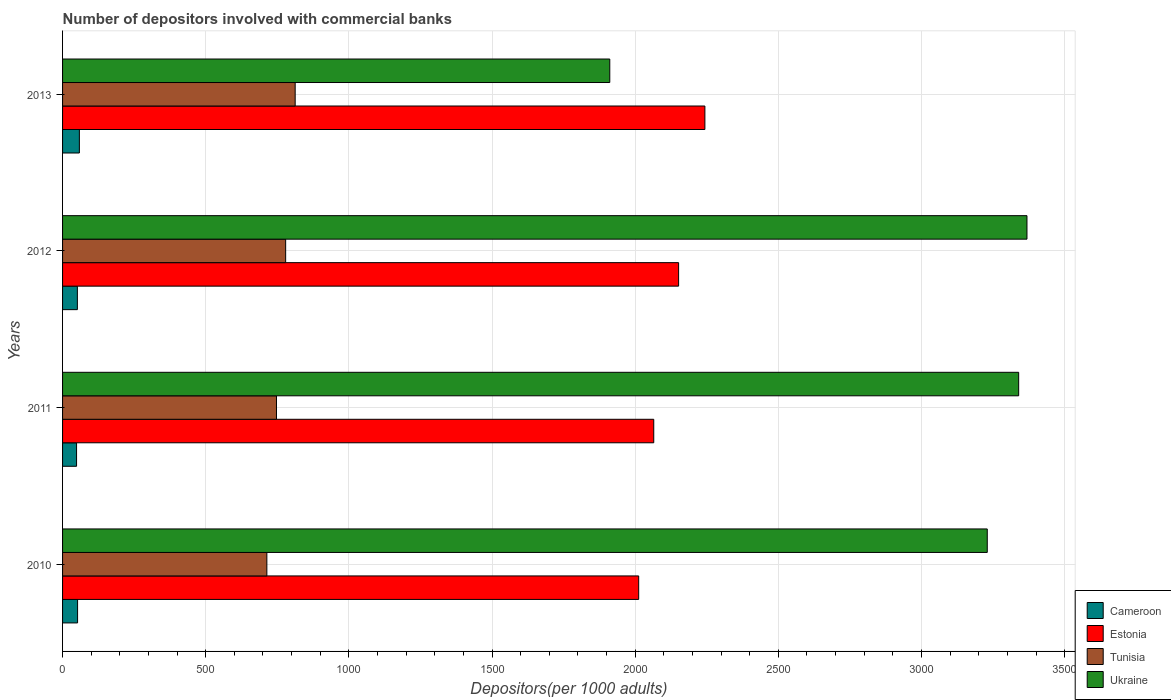Are the number of bars per tick equal to the number of legend labels?
Make the answer very short. Yes. How many bars are there on the 2nd tick from the top?
Offer a very short reply. 4. What is the label of the 4th group of bars from the top?
Give a very brief answer. 2010. What is the number of depositors involved with commercial banks in Tunisia in 2010?
Your answer should be compact. 713.56. Across all years, what is the maximum number of depositors involved with commercial banks in Estonia?
Offer a terse response. 2243.44. Across all years, what is the minimum number of depositors involved with commercial banks in Tunisia?
Offer a terse response. 713.56. What is the total number of depositors involved with commercial banks in Tunisia in the graph?
Your answer should be very brief. 3052.28. What is the difference between the number of depositors involved with commercial banks in Cameroon in 2012 and that in 2013?
Offer a terse response. -6.99. What is the difference between the number of depositors involved with commercial banks in Cameroon in 2011 and the number of depositors involved with commercial banks in Ukraine in 2013?
Keep it short and to the point. -1862.32. What is the average number of depositors involved with commercial banks in Estonia per year?
Your answer should be very brief. 2118.04. In the year 2010, what is the difference between the number of depositors involved with commercial banks in Estonia and number of depositors involved with commercial banks in Cameroon?
Offer a very short reply. 1959.79. What is the ratio of the number of depositors involved with commercial banks in Estonia in 2010 to that in 2013?
Provide a short and direct response. 0.9. Is the number of depositors involved with commercial banks in Tunisia in 2010 less than that in 2013?
Your answer should be very brief. Yes. What is the difference between the highest and the second highest number of depositors involved with commercial banks in Estonia?
Your response must be concise. 91.77. What is the difference between the highest and the lowest number of depositors involved with commercial banks in Tunisia?
Keep it short and to the point. 98.87. In how many years, is the number of depositors involved with commercial banks in Tunisia greater than the average number of depositors involved with commercial banks in Tunisia taken over all years?
Offer a terse response. 2. Is the sum of the number of depositors involved with commercial banks in Cameroon in 2011 and 2013 greater than the maximum number of depositors involved with commercial banks in Tunisia across all years?
Your answer should be very brief. No. What does the 3rd bar from the top in 2013 represents?
Your answer should be compact. Estonia. What does the 3rd bar from the bottom in 2010 represents?
Your answer should be very brief. Tunisia. How many bars are there?
Your response must be concise. 16. Are all the bars in the graph horizontal?
Make the answer very short. Yes. What is the difference between two consecutive major ticks on the X-axis?
Your answer should be compact. 500. Are the values on the major ticks of X-axis written in scientific E-notation?
Provide a succinct answer. No. Does the graph contain any zero values?
Offer a terse response. No. What is the title of the graph?
Provide a succinct answer. Number of depositors involved with commercial banks. Does "Ethiopia" appear as one of the legend labels in the graph?
Offer a terse response. No. What is the label or title of the X-axis?
Your response must be concise. Depositors(per 1000 adults). What is the Depositors(per 1000 adults) of Cameroon in 2010?
Ensure brevity in your answer.  52.42. What is the Depositors(per 1000 adults) in Estonia in 2010?
Offer a very short reply. 2012.21. What is the Depositors(per 1000 adults) of Tunisia in 2010?
Keep it short and to the point. 713.56. What is the Depositors(per 1000 adults) of Ukraine in 2010?
Your answer should be very brief. 3229.69. What is the Depositors(per 1000 adults) in Cameroon in 2011?
Make the answer very short. 48.91. What is the Depositors(per 1000 adults) in Estonia in 2011?
Keep it short and to the point. 2064.84. What is the Depositors(per 1000 adults) in Tunisia in 2011?
Ensure brevity in your answer.  747.13. What is the Depositors(per 1000 adults) in Ukraine in 2011?
Your answer should be very brief. 3339.41. What is the Depositors(per 1000 adults) of Cameroon in 2012?
Your answer should be compact. 51.71. What is the Depositors(per 1000 adults) in Estonia in 2012?
Your answer should be compact. 2151.67. What is the Depositors(per 1000 adults) in Tunisia in 2012?
Provide a short and direct response. 779.16. What is the Depositors(per 1000 adults) in Ukraine in 2012?
Your response must be concise. 3368.39. What is the Depositors(per 1000 adults) in Cameroon in 2013?
Offer a very short reply. 58.7. What is the Depositors(per 1000 adults) of Estonia in 2013?
Offer a terse response. 2243.44. What is the Depositors(per 1000 adults) in Tunisia in 2013?
Keep it short and to the point. 812.43. What is the Depositors(per 1000 adults) of Ukraine in 2013?
Ensure brevity in your answer.  1911.24. Across all years, what is the maximum Depositors(per 1000 adults) of Cameroon?
Give a very brief answer. 58.7. Across all years, what is the maximum Depositors(per 1000 adults) of Estonia?
Offer a very short reply. 2243.44. Across all years, what is the maximum Depositors(per 1000 adults) in Tunisia?
Make the answer very short. 812.43. Across all years, what is the maximum Depositors(per 1000 adults) of Ukraine?
Provide a succinct answer. 3368.39. Across all years, what is the minimum Depositors(per 1000 adults) in Cameroon?
Your response must be concise. 48.91. Across all years, what is the minimum Depositors(per 1000 adults) of Estonia?
Your answer should be very brief. 2012.21. Across all years, what is the minimum Depositors(per 1000 adults) of Tunisia?
Offer a very short reply. 713.56. Across all years, what is the minimum Depositors(per 1000 adults) in Ukraine?
Make the answer very short. 1911.24. What is the total Depositors(per 1000 adults) of Cameroon in the graph?
Provide a succinct answer. 211.74. What is the total Depositors(per 1000 adults) of Estonia in the graph?
Offer a terse response. 8472.16. What is the total Depositors(per 1000 adults) in Tunisia in the graph?
Offer a terse response. 3052.28. What is the total Depositors(per 1000 adults) of Ukraine in the graph?
Give a very brief answer. 1.18e+04. What is the difference between the Depositors(per 1000 adults) in Cameroon in 2010 and that in 2011?
Provide a succinct answer. 3.51. What is the difference between the Depositors(per 1000 adults) of Estonia in 2010 and that in 2011?
Ensure brevity in your answer.  -52.62. What is the difference between the Depositors(per 1000 adults) in Tunisia in 2010 and that in 2011?
Offer a terse response. -33.57. What is the difference between the Depositors(per 1000 adults) in Ukraine in 2010 and that in 2011?
Offer a very short reply. -109.71. What is the difference between the Depositors(per 1000 adults) in Cameroon in 2010 and that in 2012?
Give a very brief answer. 0.71. What is the difference between the Depositors(per 1000 adults) in Estonia in 2010 and that in 2012?
Make the answer very short. -139.46. What is the difference between the Depositors(per 1000 adults) of Tunisia in 2010 and that in 2012?
Offer a very short reply. -65.61. What is the difference between the Depositors(per 1000 adults) in Ukraine in 2010 and that in 2012?
Provide a short and direct response. -138.7. What is the difference between the Depositors(per 1000 adults) in Cameroon in 2010 and that in 2013?
Offer a terse response. -6.28. What is the difference between the Depositors(per 1000 adults) in Estonia in 2010 and that in 2013?
Offer a very short reply. -231.23. What is the difference between the Depositors(per 1000 adults) of Tunisia in 2010 and that in 2013?
Your answer should be very brief. -98.87. What is the difference between the Depositors(per 1000 adults) in Ukraine in 2010 and that in 2013?
Offer a terse response. 1318.46. What is the difference between the Depositors(per 1000 adults) of Cameroon in 2011 and that in 2012?
Offer a very short reply. -2.8. What is the difference between the Depositors(per 1000 adults) of Estonia in 2011 and that in 2012?
Keep it short and to the point. -86.83. What is the difference between the Depositors(per 1000 adults) of Tunisia in 2011 and that in 2012?
Provide a succinct answer. -32.03. What is the difference between the Depositors(per 1000 adults) of Ukraine in 2011 and that in 2012?
Your answer should be compact. -28.98. What is the difference between the Depositors(per 1000 adults) in Cameroon in 2011 and that in 2013?
Your response must be concise. -9.79. What is the difference between the Depositors(per 1000 adults) in Estonia in 2011 and that in 2013?
Provide a succinct answer. -178.61. What is the difference between the Depositors(per 1000 adults) in Tunisia in 2011 and that in 2013?
Provide a succinct answer. -65.3. What is the difference between the Depositors(per 1000 adults) in Ukraine in 2011 and that in 2013?
Provide a succinct answer. 1428.17. What is the difference between the Depositors(per 1000 adults) in Cameroon in 2012 and that in 2013?
Provide a succinct answer. -6.99. What is the difference between the Depositors(per 1000 adults) in Estonia in 2012 and that in 2013?
Provide a succinct answer. -91.77. What is the difference between the Depositors(per 1000 adults) of Tunisia in 2012 and that in 2013?
Keep it short and to the point. -33.26. What is the difference between the Depositors(per 1000 adults) of Ukraine in 2012 and that in 2013?
Your answer should be compact. 1457.15. What is the difference between the Depositors(per 1000 adults) of Cameroon in 2010 and the Depositors(per 1000 adults) of Estonia in 2011?
Provide a short and direct response. -2012.42. What is the difference between the Depositors(per 1000 adults) of Cameroon in 2010 and the Depositors(per 1000 adults) of Tunisia in 2011?
Your answer should be compact. -694.71. What is the difference between the Depositors(per 1000 adults) in Cameroon in 2010 and the Depositors(per 1000 adults) in Ukraine in 2011?
Give a very brief answer. -3286.98. What is the difference between the Depositors(per 1000 adults) of Estonia in 2010 and the Depositors(per 1000 adults) of Tunisia in 2011?
Make the answer very short. 1265.08. What is the difference between the Depositors(per 1000 adults) in Estonia in 2010 and the Depositors(per 1000 adults) in Ukraine in 2011?
Ensure brevity in your answer.  -1327.19. What is the difference between the Depositors(per 1000 adults) in Tunisia in 2010 and the Depositors(per 1000 adults) in Ukraine in 2011?
Offer a terse response. -2625.85. What is the difference between the Depositors(per 1000 adults) of Cameroon in 2010 and the Depositors(per 1000 adults) of Estonia in 2012?
Your answer should be very brief. -2099.25. What is the difference between the Depositors(per 1000 adults) of Cameroon in 2010 and the Depositors(per 1000 adults) of Tunisia in 2012?
Offer a terse response. -726.74. What is the difference between the Depositors(per 1000 adults) in Cameroon in 2010 and the Depositors(per 1000 adults) in Ukraine in 2012?
Ensure brevity in your answer.  -3315.97. What is the difference between the Depositors(per 1000 adults) in Estonia in 2010 and the Depositors(per 1000 adults) in Tunisia in 2012?
Give a very brief answer. 1233.05. What is the difference between the Depositors(per 1000 adults) in Estonia in 2010 and the Depositors(per 1000 adults) in Ukraine in 2012?
Provide a short and direct response. -1356.17. What is the difference between the Depositors(per 1000 adults) in Tunisia in 2010 and the Depositors(per 1000 adults) in Ukraine in 2012?
Make the answer very short. -2654.83. What is the difference between the Depositors(per 1000 adults) in Cameroon in 2010 and the Depositors(per 1000 adults) in Estonia in 2013?
Provide a short and direct response. -2191.02. What is the difference between the Depositors(per 1000 adults) of Cameroon in 2010 and the Depositors(per 1000 adults) of Tunisia in 2013?
Provide a short and direct response. -760. What is the difference between the Depositors(per 1000 adults) in Cameroon in 2010 and the Depositors(per 1000 adults) in Ukraine in 2013?
Keep it short and to the point. -1858.81. What is the difference between the Depositors(per 1000 adults) in Estonia in 2010 and the Depositors(per 1000 adults) in Tunisia in 2013?
Provide a short and direct response. 1199.79. What is the difference between the Depositors(per 1000 adults) in Estonia in 2010 and the Depositors(per 1000 adults) in Ukraine in 2013?
Offer a terse response. 100.98. What is the difference between the Depositors(per 1000 adults) in Tunisia in 2010 and the Depositors(per 1000 adults) in Ukraine in 2013?
Ensure brevity in your answer.  -1197.68. What is the difference between the Depositors(per 1000 adults) in Cameroon in 2011 and the Depositors(per 1000 adults) in Estonia in 2012?
Your answer should be very brief. -2102.76. What is the difference between the Depositors(per 1000 adults) of Cameroon in 2011 and the Depositors(per 1000 adults) of Tunisia in 2012?
Give a very brief answer. -730.25. What is the difference between the Depositors(per 1000 adults) in Cameroon in 2011 and the Depositors(per 1000 adults) in Ukraine in 2012?
Provide a succinct answer. -3319.48. What is the difference between the Depositors(per 1000 adults) in Estonia in 2011 and the Depositors(per 1000 adults) in Tunisia in 2012?
Give a very brief answer. 1285.67. What is the difference between the Depositors(per 1000 adults) of Estonia in 2011 and the Depositors(per 1000 adults) of Ukraine in 2012?
Your answer should be very brief. -1303.55. What is the difference between the Depositors(per 1000 adults) in Tunisia in 2011 and the Depositors(per 1000 adults) in Ukraine in 2012?
Your answer should be very brief. -2621.26. What is the difference between the Depositors(per 1000 adults) in Cameroon in 2011 and the Depositors(per 1000 adults) in Estonia in 2013?
Your response must be concise. -2194.53. What is the difference between the Depositors(per 1000 adults) in Cameroon in 2011 and the Depositors(per 1000 adults) in Tunisia in 2013?
Your answer should be very brief. -763.52. What is the difference between the Depositors(per 1000 adults) of Cameroon in 2011 and the Depositors(per 1000 adults) of Ukraine in 2013?
Keep it short and to the point. -1862.32. What is the difference between the Depositors(per 1000 adults) of Estonia in 2011 and the Depositors(per 1000 adults) of Tunisia in 2013?
Ensure brevity in your answer.  1252.41. What is the difference between the Depositors(per 1000 adults) of Estonia in 2011 and the Depositors(per 1000 adults) of Ukraine in 2013?
Your response must be concise. 153.6. What is the difference between the Depositors(per 1000 adults) in Tunisia in 2011 and the Depositors(per 1000 adults) in Ukraine in 2013?
Make the answer very short. -1164.11. What is the difference between the Depositors(per 1000 adults) in Cameroon in 2012 and the Depositors(per 1000 adults) in Estonia in 2013?
Make the answer very short. -2191.73. What is the difference between the Depositors(per 1000 adults) in Cameroon in 2012 and the Depositors(per 1000 adults) in Tunisia in 2013?
Ensure brevity in your answer.  -760.72. What is the difference between the Depositors(per 1000 adults) of Cameroon in 2012 and the Depositors(per 1000 adults) of Ukraine in 2013?
Offer a very short reply. -1859.53. What is the difference between the Depositors(per 1000 adults) in Estonia in 2012 and the Depositors(per 1000 adults) in Tunisia in 2013?
Give a very brief answer. 1339.24. What is the difference between the Depositors(per 1000 adults) in Estonia in 2012 and the Depositors(per 1000 adults) in Ukraine in 2013?
Your answer should be very brief. 240.43. What is the difference between the Depositors(per 1000 adults) of Tunisia in 2012 and the Depositors(per 1000 adults) of Ukraine in 2013?
Provide a short and direct response. -1132.07. What is the average Depositors(per 1000 adults) in Cameroon per year?
Make the answer very short. 52.94. What is the average Depositors(per 1000 adults) in Estonia per year?
Ensure brevity in your answer.  2118.04. What is the average Depositors(per 1000 adults) of Tunisia per year?
Give a very brief answer. 763.07. What is the average Depositors(per 1000 adults) in Ukraine per year?
Your answer should be compact. 2962.18. In the year 2010, what is the difference between the Depositors(per 1000 adults) in Cameroon and Depositors(per 1000 adults) in Estonia?
Keep it short and to the point. -1959.79. In the year 2010, what is the difference between the Depositors(per 1000 adults) of Cameroon and Depositors(per 1000 adults) of Tunisia?
Provide a short and direct response. -661.14. In the year 2010, what is the difference between the Depositors(per 1000 adults) in Cameroon and Depositors(per 1000 adults) in Ukraine?
Offer a terse response. -3177.27. In the year 2010, what is the difference between the Depositors(per 1000 adults) in Estonia and Depositors(per 1000 adults) in Tunisia?
Provide a succinct answer. 1298.66. In the year 2010, what is the difference between the Depositors(per 1000 adults) in Estonia and Depositors(per 1000 adults) in Ukraine?
Keep it short and to the point. -1217.48. In the year 2010, what is the difference between the Depositors(per 1000 adults) in Tunisia and Depositors(per 1000 adults) in Ukraine?
Ensure brevity in your answer.  -2516.14. In the year 2011, what is the difference between the Depositors(per 1000 adults) of Cameroon and Depositors(per 1000 adults) of Estonia?
Provide a short and direct response. -2015.93. In the year 2011, what is the difference between the Depositors(per 1000 adults) of Cameroon and Depositors(per 1000 adults) of Tunisia?
Keep it short and to the point. -698.22. In the year 2011, what is the difference between the Depositors(per 1000 adults) in Cameroon and Depositors(per 1000 adults) in Ukraine?
Give a very brief answer. -3290.5. In the year 2011, what is the difference between the Depositors(per 1000 adults) of Estonia and Depositors(per 1000 adults) of Tunisia?
Offer a very short reply. 1317.71. In the year 2011, what is the difference between the Depositors(per 1000 adults) of Estonia and Depositors(per 1000 adults) of Ukraine?
Keep it short and to the point. -1274.57. In the year 2011, what is the difference between the Depositors(per 1000 adults) in Tunisia and Depositors(per 1000 adults) in Ukraine?
Offer a terse response. -2592.28. In the year 2012, what is the difference between the Depositors(per 1000 adults) in Cameroon and Depositors(per 1000 adults) in Estonia?
Your answer should be very brief. -2099.96. In the year 2012, what is the difference between the Depositors(per 1000 adults) of Cameroon and Depositors(per 1000 adults) of Tunisia?
Give a very brief answer. -727.45. In the year 2012, what is the difference between the Depositors(per 1000 adults) of Cameroon and Depositors(per 1000 adults) of Ukraine?
Your answer should be very brief. -3316.68. In the year 2012, what is the difference between the Depositors(per 1000 adults) in Estonia and Depositors(per 1000 adults) in Tunisia?
Offer a very short reply. 1372.51. In the year 2012, what is the difference between the Depositors(per 1000 adults) of Estonia and Depositors(per 1000 adults) of Ukraine?
Keep it short and to the point. -1216.72. In the year 2012, what is the difference between the Depositors(per 1000 adults) in Tunisia and Depositors(per 1000 adults) in Ukraine?
Offer a very short reply. -2589.23. In the year 2013, what is the difference between the Depositors(per 1000 adults) of Cameroon and Depositors(per 1000 adults) of Estonia?
Provide a short and direct response. -2184.74. In the year 2013, what is the difference between the Depositors(per 1000 adults) of Cameroon and Depositors(per 1000 adults) of Tunisia?
Ensure brevity in your answer.  -753.72. In the year 2013, what is the difference between the Depositors(per 1000 adults) in Cameroon and Depositors(per 1000 adults) in Ukraine?
Make the answer very short. -1852.53. In the year 2013, what is the difference between the Depositors(per 1000 adults) in Estonia and Depositors(per 1000 adults) in Tunisia?
Make the answer very short. 1431.02. In the year 2013, what is the difference between the Depositors(per 1000 adults) of Estonia and Depositors(per 1000 adults) of Ukraine?
Make the answer very short. 332.21. In the year 2013, what is the difference between the Depositors(per 1000 adults) of Tunisia and Depositors(per 1000 adults) of Ukraine?
Provide a succinct answer. -1098.81. What is the ratio of the Depositors(per 1000 adults) in Cameroon in 2010 to that in 2011?
Keep it short and to the point. 1.07. What is the ratio of the Depositors(per 1000 adults) of Estonia in 2010 to that in 2011?
Provide a short and direct response. 0.97. What is the ratio of the Depositors(per 1000 adults) of Tunisia in 2010 to that in 2011?
Provide a short and direct response. 0.96. What is the ratio of the Depositors(per 1000 adults) of Ukraine in 2010 to that in 2011?
Ensure brevity in your answer.  0.97. What is the ratio of the Depositors(per 1000 adults) in Cameroon in 2010 to that in 2012?
Your answer should be compact. 1.01. What is the ratio of the Depositors(per 1000 adults) of Estonia in 2010 to that in 2012?
Ensure brevity in your answer.  0.94. What is the ratio of the Depositors(per 1000 adults) in Tunisia in 2010 to that in 2012?
Provide a succinct answer. 0.92. What is the ratio of the Depositors(per 1000 adults) of Ukraine in 2010 to that in 2012?
Your response must be concise. 0.96. What is the ratio of the Depositors(per 1000 adults) of Cameroon in 2010 to that in 2013?
Your answer should be very brief. 0.89. What is the ratio of the Depositors(per 1000 adults) of Estonia in 2010 to that in 2013?
Offer a very short reply. 0.9. What is the ratio of the Depositors(per 1000 adults) of Tunisia in 2010 to that in 2013?
Provide a short and direct response. 0.88. What is the ratio of the Depositors(per 1000 adults) in Ukraine in 2010 to that in 2013?
Provide a short and direct response. 1.69. What is the ratio of the Depositors(per 1000 adults) of Cameroon in 2011 to that in 2012?
Offer a terse response. 0.95. What is the ratio of the Depositors(per 1000 adults) in Estonia in 2011 to that in 2012?
Your response must be concise. 0.96. What is the ratio of the Depositors(per 1000 adults) of Tunisia in 2011 to that in 2012?
Your answer should be compact. 0.96. What is the ratio of the Depositors(per 1000 adults) in Ukraine in 2011 to that in 2012?
Provide a short and direct response. 0.99. What is the ratio of the Depositors(per 1000 adults) in Cameroon in 2011 to that in 2013?
Give a very brief answer. 0.83. What is the ratio of the Depositors(per 1000 adults) in Estonia in 2011 to that in 2013?
Your answer should be very brief. 0.92. What is the ratio of the Depositors(per 1000 adults) in Tunisia in 2011 to that in 2013?
Make the answer very short. 0.92. What is the ratio of the Depositors(per 1000 adults) of Ukraine in 2011 to that in 2013?
Provide a succinct answer. 1.75. What is the ratio of the Depositors(per 1000 adults) in Cameroon in 2012 to that in 2013?
Ensure brevity in your answer.  0.88. What is the ratio of the Depositors(per 1000 adults) of Estonia in 2012 to that in 2013?
Ensure brevity in your answer.  0.96. What is the ratio of the Depositors(per 1000 adults) of Tunisia in 2012 to that in 2013?
Your answer should be compact. 0.96. What is the ratio of the Depositors(per 1000 adults) of Ukraine in 2012 to that in 2013?
Offer a very short reply. 1.76. What is the difference between the highest and the second highest Depositors(per 1000 adults) in Cameroon?
Offer a very short reply. 6.28. What is the difference between the highest and the second highest Depositors(per 1000 adults) of Estonia?
Ensure brevity in your answer.  91.77. What is the difference between the highest and the second highest Depositors(per 1000 adults) of Tunisia?
Offer a very short reply. 33.26. What is the difference between the highest and the second highest Depositors(per 1000 adults) of Ukraine?
Make the answer very short. 28.98. What is the difference between the highest and the lowest Depositors(per 1000 adults) in Cameroon?
Keep it short and to the point. 9.79. What is the difference between the highest and the lowest Depositors(per 1000 adults) in Estonia?
Make the answer very short. 231.23. What is the difference between the highest and the lowest Depositors(per 1000 adults) in Tunisia?
Keep it short and to the point. 98.87. What is the difference between the highest and the lowest Depositors(per 1000 adults) in Ukraine?
Your answer should be compact. 1457.15. 